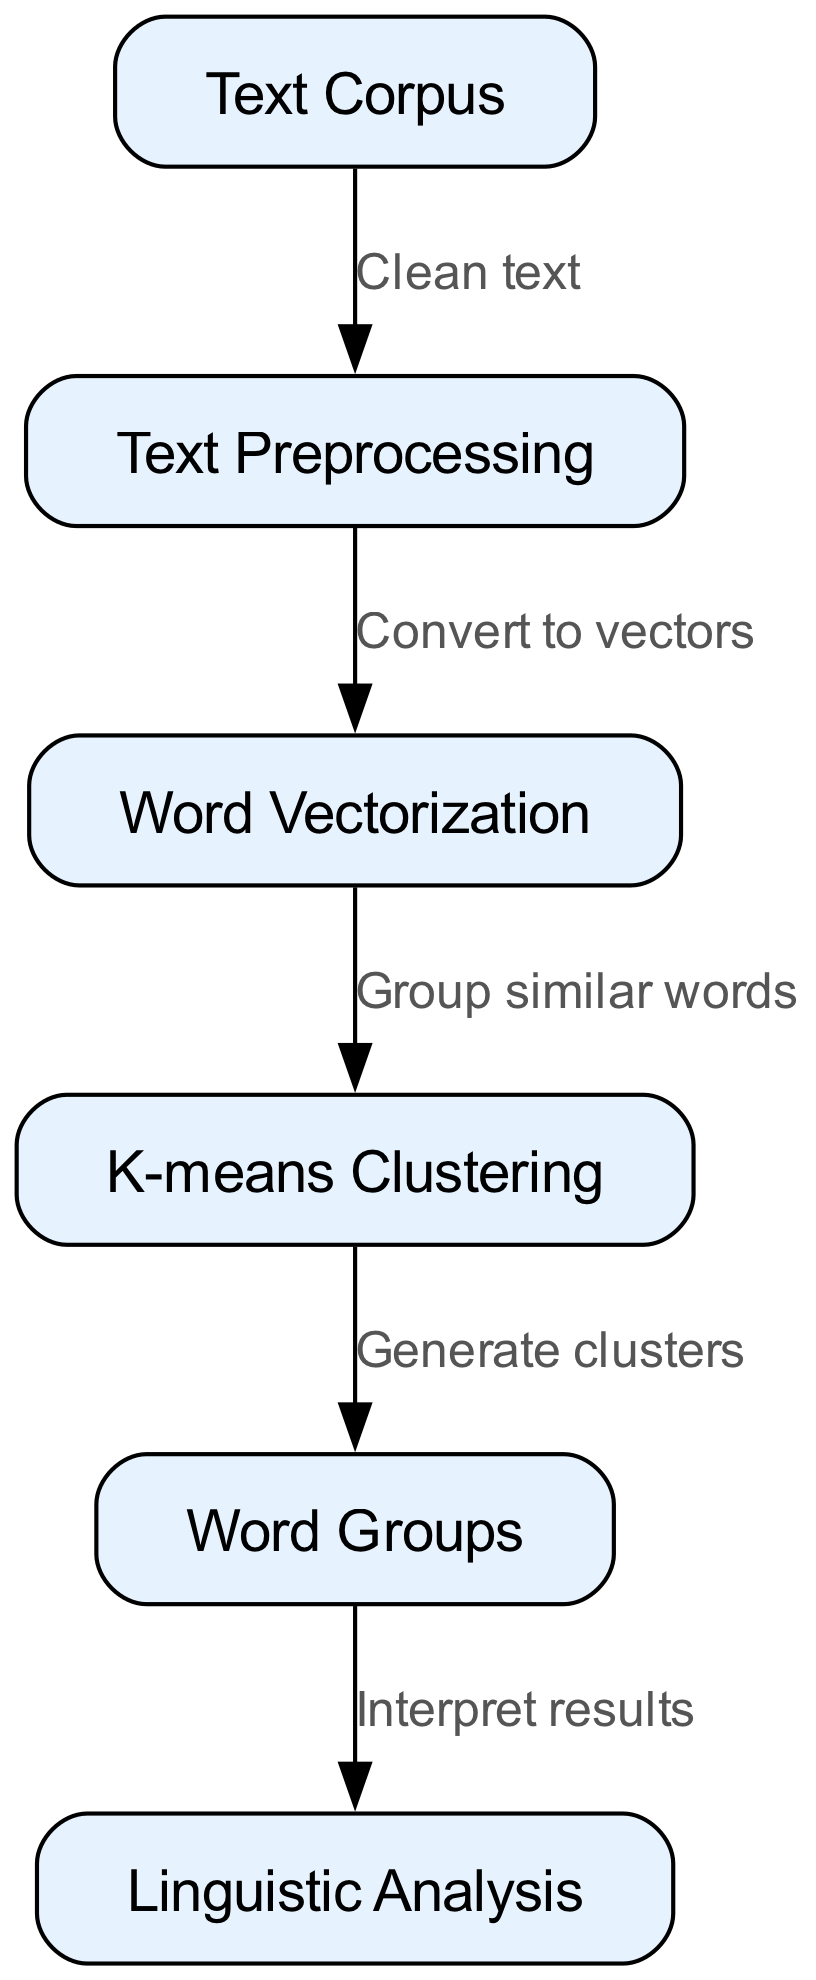What is the first step in the clustering algorithm process? The first step listed in the diagram is "Text Preprocessing," which follows the "Text Corpus" node. This indicates that the process begins with preparing the text for analysis.
Answer: Text Preprocessing How many nodes are present in the diagram? To find the number of nodes, we count each unique labeled box in the diagram. The nodes in the diagram are: "Text Corpus," "Text Preprocessing," "Word Vectorization," "K-means Clustering," "Word Groups," and "Linguistic Analysis," totaling six distinct nodes.
Answer: 6 What is the output of the K-means Clustering step? The output of the "K-means Clustering" node directly leads to the "Word Groups" node, as indicated in the diagram. This means the result of K-means Clustering is the generation of clusters, which are grouped words.
Answer: Word Groups What is the relationship between Text Preprocessing and Word Vectorization? The relationship is that Text Preprocessing leads to Word Vectorization with the label "Convert to vectors," establishing that preprocessing steps are necessary before vectorization can occur.
Answer: Convert to vectors Which node directly precedes the Linguistic Analysis step? Looking at the diagram flow, the node that leads into "Linguistic Analysis" is "Word Groups," meaning that the analysis is contingent upon the output derived from the word clustering process.
Answer: Word Groups What action is associated with moving from vectorization to K-means Clustering? The action connecting these two nodes is "Group similar words," suggesting that the transformed word vectors are then organized into clusters based on their similarity.
Answer: Group similar words What does the arrow labeled "Generate clusters" indicate? The arrow shows that following the processing in K-means Clustering, the next action is to create and define word clusters, leading to the output "Word Groups."
Answer: Generate clusters Which type of analysis is performed after the clustering process? The analysis performed after generating word groups is labeled "Linguistic Analysis," indicating an interpretation of the clusters formed.
Answer: Linguistic Analysis 